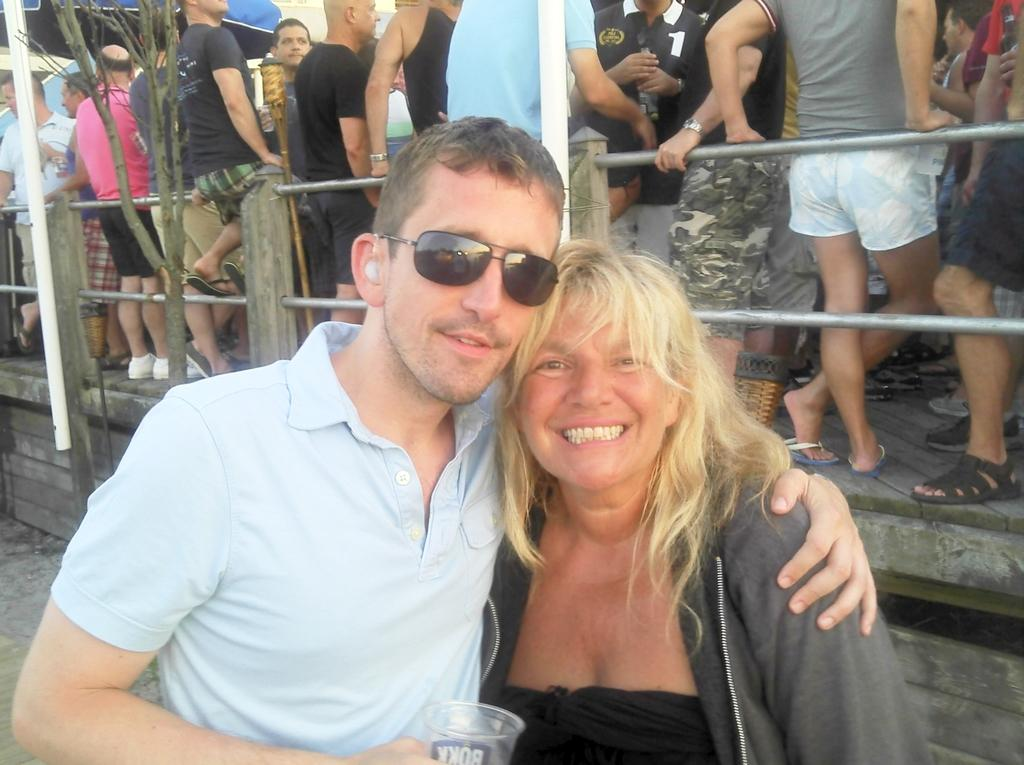Who are the people in the image? There is a man and a woman in the image. What expressions do the man and woman have? Both the man and the woman are smiling. Can you describe the people in the background of the image? There are people standing in the background of the image. What material are the rods visible in the image made of? The metal rods are visible in the image. What natural element is in the middle of the image? There is a tree in the middle of the image. What type of pie is being served to the nation in the image? There is no pie or nation present in the image; it features a man, a woman, people in the background, metal rods, and a tree. 